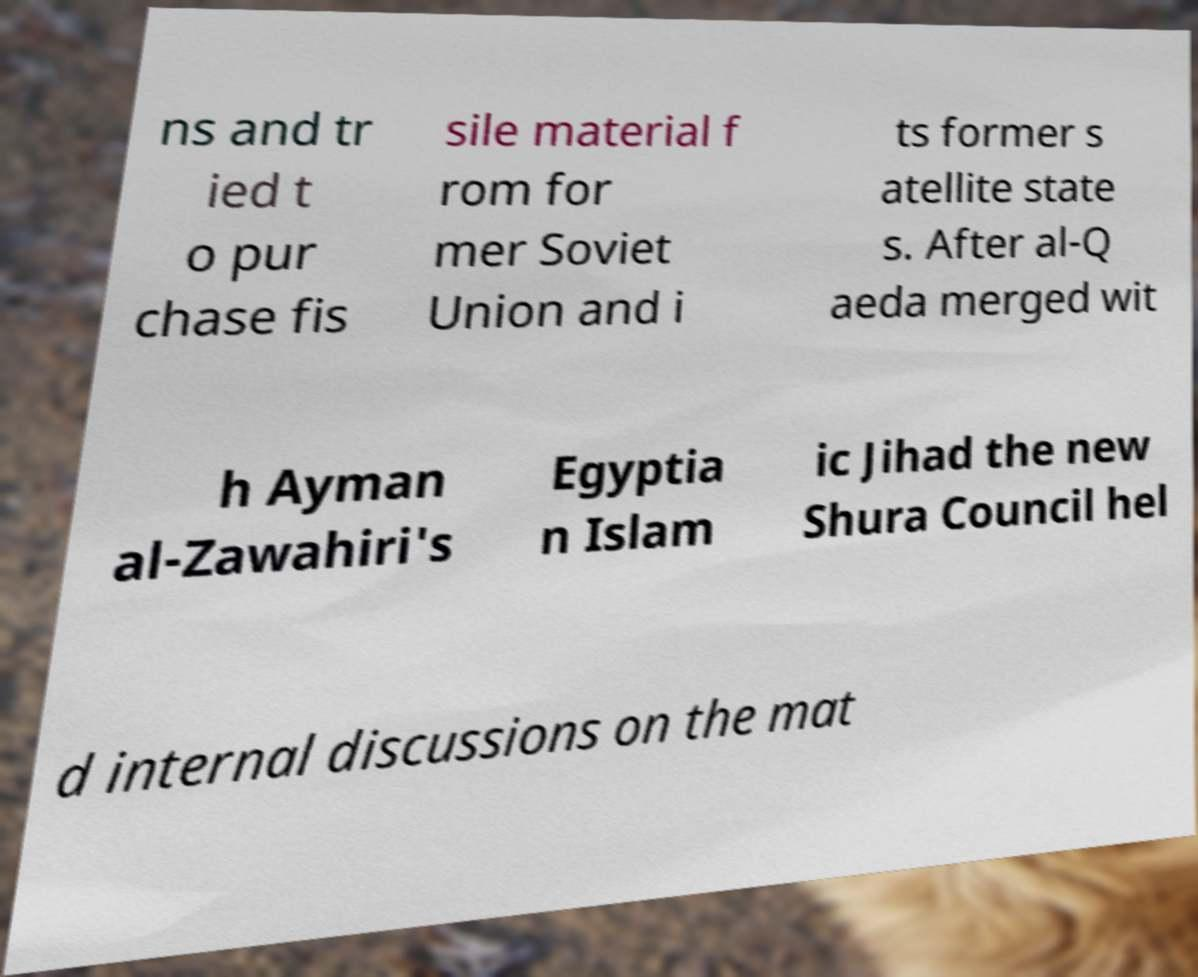I need the written content from this picture converted into text. Can you do that? ns and tr ied t o pur chase fis sile material f rom for mer Soviet Union and i ts former s atellite state s. After al-Q aeda merged wit h Ayman al-Zawahiri's Egyptia n Islam ic Jihad the new Shura Council hel d internal discussions on the mat 